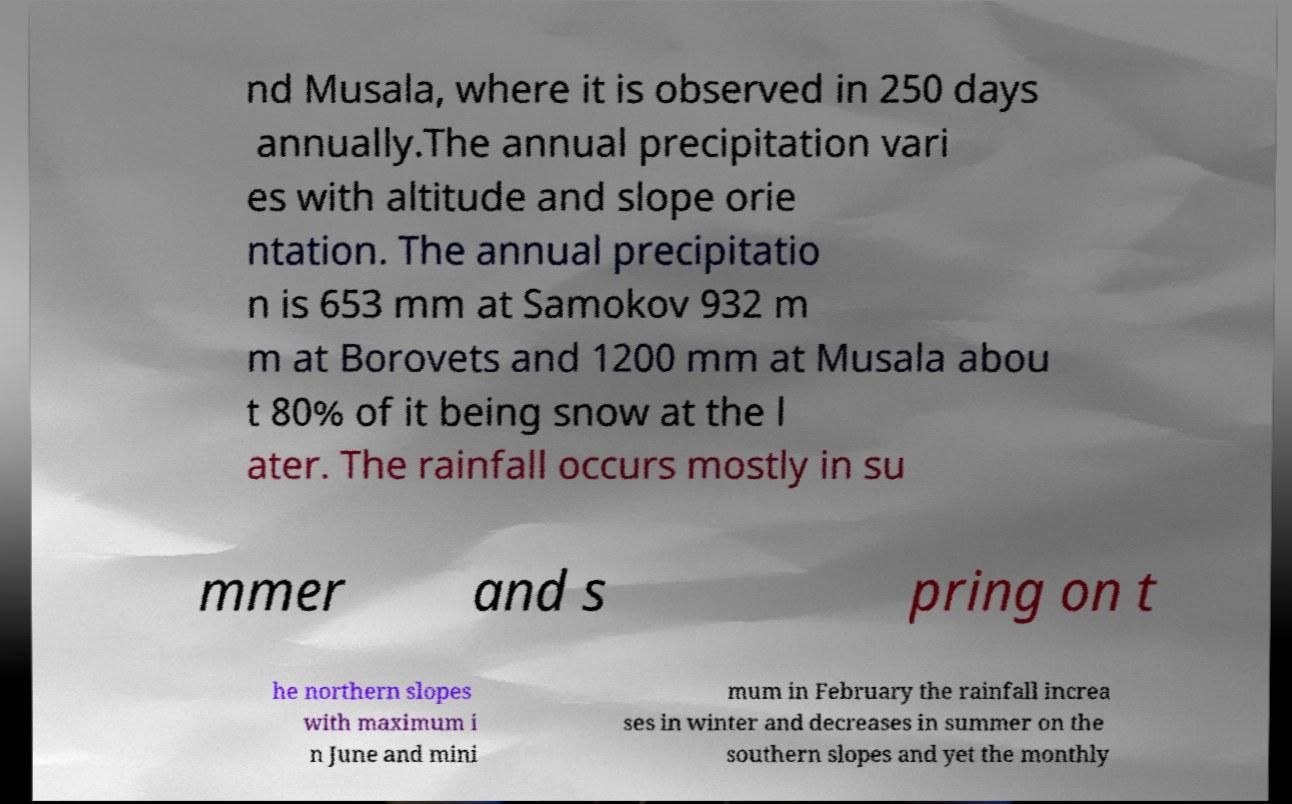Please read and relay the text visible in this image. What does it say? nd Musala, where it is observed in 250 days annually.The annual precipitation vari es with altitude and slope orie ntation. The annual precipitatio n is 653 mm at Samokov 932 m m at Borovets and 1200 mm at Musala abou t 80% of it being snow at the l ater. The rainfall occurs mostly in su mmer and s pring on t he northern slopes with maximum i n June and mini mum in February the rainfall increa ses in winter and decreases in summer on the southern slopes and yet the monthly 